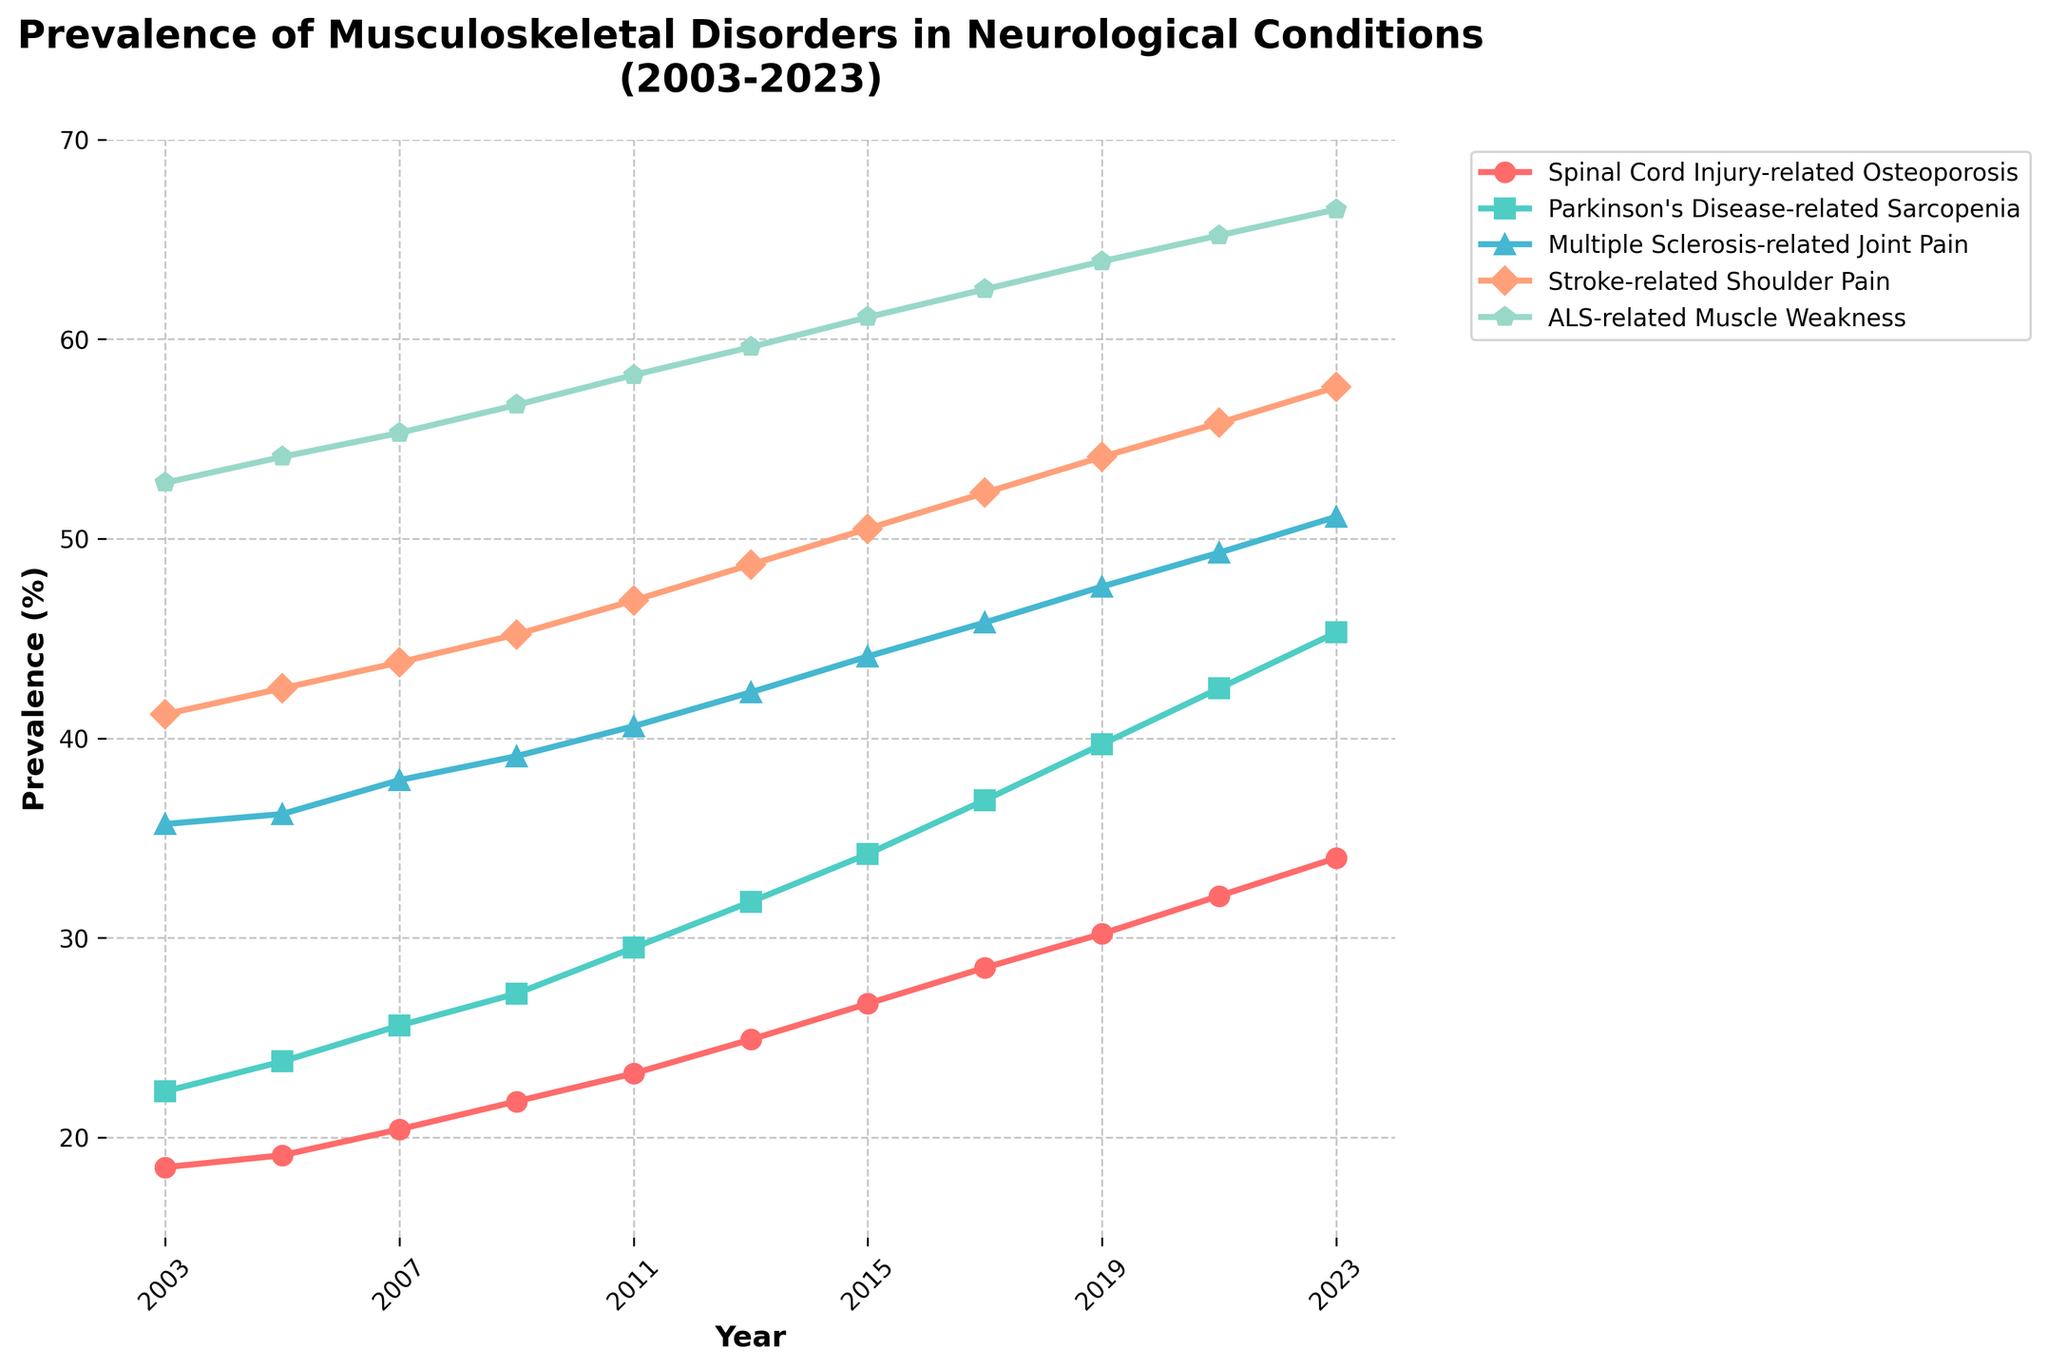what is the overall trend for ALS-related Muscle Weakness from 2003 to 2023? ALS-related Muscle Weakness shows a clear increasing trend from 52.8% in 2003 to 66.5% in 2023. This is visible by observing the consistent upward trajectory of the turquoise line with pentagon markers representing ALS-related Muscle Weakness on the line chart.
Answer: increasing Which disorder had the highest prevalence in 2023? In 2023, ALS-related Muscle Weakness had the highest prevalence, as indicated by the turquoise line reaching 66.5% on the chart. This is higher than the other disorders’ prevalence rates represented by their respective lines and markers.
Answer: ALS-related Muscle Weakness What's the average prevalence of Stroke-related Shoulder Pain over the years displayed on the chart? To find the average of Stroke-related Shoulder Pain, sum the prevalence values for each year and divide by the number of years. Sum: (41.2 + 42.5 + 43.8 + 45.2 + 46.9 + 48.7 + 50.5 + 52.3 + 54.1 + 55.8 + 57.6) = 538.6. Number of years: 11. Average = 538.6 / 11 ≈ 48.96%.
Answer: 48.96% Compare the prevalence trends of Spinal Cord Injury-related Osteoporosis and Parkinson's Disease-related Sarcopenia. Which has grown more rapidly? Both disorders show an increasing trend, but Spinal Cord Injury-related Osteoporosis started at 18.5% in 2003 and increased to 34.0% in 2023, while Parkinson's Disease-related Sarcopenia started at 22.3% and increased to 45.3%. By comparing the growth in values, Parkinson's Disease-related Sarcopenia (from 22.3% to 45.3%, an increase of 23%) has grown more rapidly than Spinal Cord Injury-related Osteoporosis (from 18.5% to 34.0%, an increase of 15.5%).
Answer: Parkinson's Disease-related Sarcopenia Which disorder had the lowest prevalence in 2011? Observing the chart, the disorder with the lowest prevalence in 2011 is Spinal Cord Injury-related Osteoporosis, marked by the red line with small circle markers, at 23.2%.
Answer: Spinal Cord Injury-related Osteoporosis How much higher is the prevalence of Multiple Sclerosis-related Joint Pain in 2023 compared to its prevalence in 2003? In 2023, the prevalence of Multiple Sclerosis-related Joint Pain is 51.1%, while in 2003 it was 35.7%. The difference between these two points is 51.1% - 35.7% = 15.4%.
Answer: 15.4% What is the median value for Parkinson's Disease-related Sarcopenia prevalence over the years? First, list the prevalence values for Parkinson's Disease-related Sarcopenia: 22.3%, 23.8%, 25.6%, 27.2%, 29.5%, 31.8%, 34.2%, 36.9%, 39.7%, 42.5%, 45.3%. The median value is the middle value in this ordered list, which is 31.8% (the 6th value).
Answer: 31.8% In which year did Stroke-related Shoulder Pain first surpass 50% prevalence? Looking at the orange line with diamond markers representing Stroke-related Shoulder Pain, it first surpasses 50% in 2015, where the prevalence rate is shown as 50.5%.
Answer: 2015 Compare the prevalence of Spinal Cord Injury-related Osteoporosis and ALS-related Muscle Weakness in 2021. Which has the greater prevalence? In 2021, Spinal Cord Injury-related Osteoporosis has a prevalence of 32.1%, while ALS-related Muscle Weakness is at 65.2%. The green line with pentagon markers representing ALS-related Muscle Weakness is higher than the red line with small circle markers for Spinal Cord Injury-related Osteoporosis in 2021, indicating a greater prevalence for ALS-related Muscle Weakness.
Answer: ALS-related Muscle Weakness 